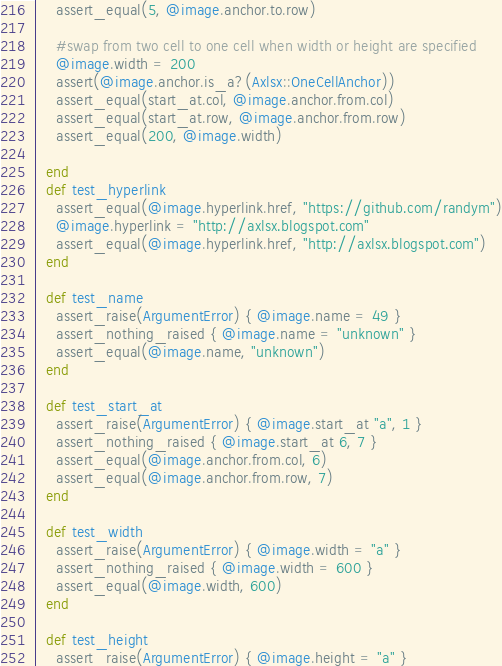<code> <loc_0><loc_0><loc_500><loc_500><_Ruby_>    assert_equal(5, @image.anchor.to.row)
  
    #swap from two cell to one cell when width or height are specified
    @image.width = 200
    assert(@image.anchor.is_a?(Axlsx::OneCellAnchor))
    assert_equal(start_at.col, @image.anchor.from.col)
    assert_equal(start_at.row, @image.anchor.from.row)
    assert_equal(200, @image.width)
  
  end
  def test_hyperlink
    assert_equal(@image.hyperlink.href, "https://github.com/randym")
    @image.hyperlink = "http://axlsx.blogspot.com"
    assert_equal(@image.hyperlink.href, "http://axlsx.blogspot.com")
  end

  def test_name
    assert_raise(ArgumentError) { @image.name = 49 }
    assert_nothing_raised { @image.name = "unknown" }
    assert_equal(@image.name, "unknown")
  end

  def test_start_at
    assert_raise(ArgumentError) { @image.start_at "a", 1 }
    assert_nothing_raised { @image.start_at 6, 7 }
    assert_equal(@image.anchor.from.col, 6)
    assert_equal(@image.anchor.from.row, 7)
  end

  def test_width
    assert_raise(ArgumentError) { @image.width = "a" }
    assert_nothing_raised { @image.width = 600 }
    assert_equal(@image.width, 600)
  end

  def test_height
    assert_raise(ArgumentError) { @image.height = "a" }</code> 